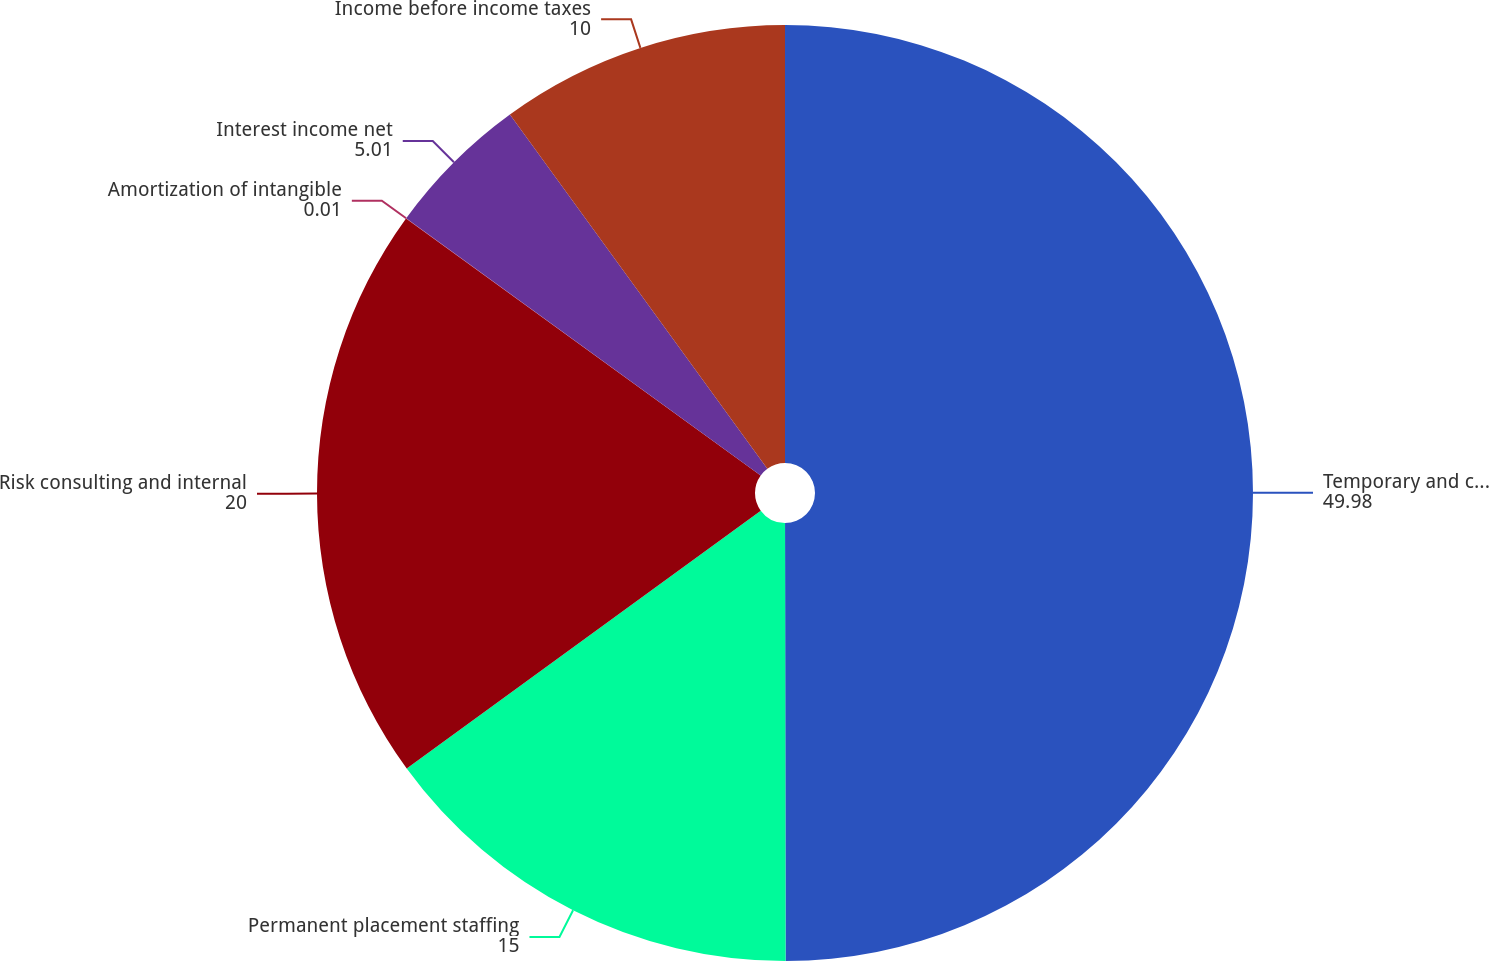Convert chart. <chart><loc_0><loc_0><loc_500><loc_500><pie_chart><fcel>Temporary and consultant<fcel>Permanent placement staffing<fcel>Risk consulting and internal<fcel>Amortization of intangible<fcel>Interest income net<fcel>Income before income taxes<nl><fcel>49.98%<fcel>15.0%<fcel>20.0%<fcel>0.01%<fcel>5.01%<fcel>10.0%<nl></chart> 